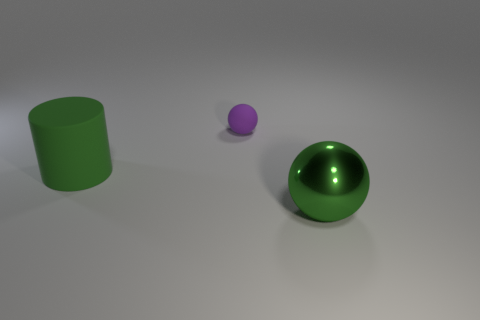There is a metal sphere right of the small ball; is it the same color as the thing left of the small sphere?
Make the answer very short. Yes. There is a matte cylinder that is the same size as the metallic thing; what is its color?
Offer a very short reply. Green. Are there the same number of small purple spheres that are in front of the green shiny thing and tiny rubber objects that are behind the purple ball?
Give a very brief answer. Yes. What is the material of the ball that is in front of the sphere that is behind the big matte cylinder?
Your answer should be very brief. Metal. How many things are green objects or purple balls?
Offer a terse response. 3. There is a sphere that is the same color as the big cylinder; what size is it?
Keep it short and to the point. Large. Are there fewer big purple matte things than tiny things?
Your response must be concise. Yes. What size is the cylinder that is made of the same material as the small purple object?
Offer a terse response. Large. How big is the green cylinder?
Provide a short and direct response. Large. The shiny object is what shape?
Give a very brief answer. Sphere. 